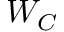Convert formula to latex. <formula><loc_0><loc_0><loc_500><loc_500>W _ { C }</formula> 